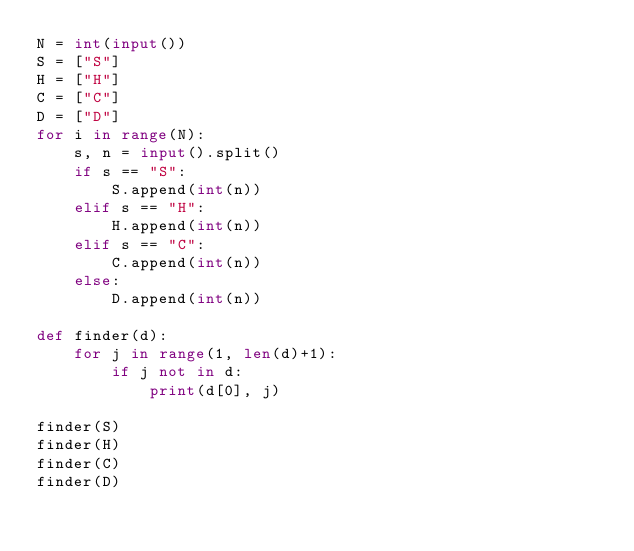Convert code to text. <code><loc_0><loc_0><loc_500><loc_500><_Python_>N = int(input())
S = ["S"]
H = ["H"]
C = ["C"]
D = ["D"]
for i in range(N):
    s, n = input().split()
    if s == "S":
        S.append(int(n))
    elif s == "H":
        H.append(int(n))
    elif s == "C":
        C.append(int(n))
    else:
        D.append(int(n))

def finder(d):
    for j in range(1, len(d)+1):
        if j not in d:
            print(d[0], j)

finder(S)
finder(H)
finder(C)
finder(D)</code> 